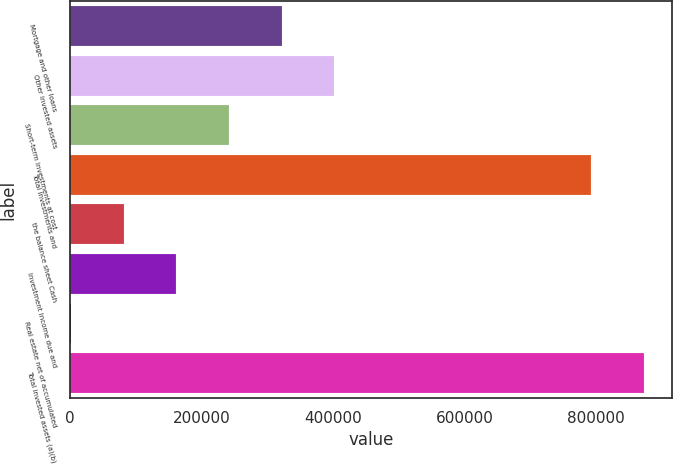Convert chart. <chart><loc_0><loc_0><loc_500><loc_500><bar_chart><fcel>Mortgage and other loans<fcel>Other invested assets<fcel>Short-term investments at cost<fcel>Total investments and<fcel>the balance sheet Cash<fcel>Investment income due and<fcel>Real estate net of accumulated<fcel>Total invested assets (a)(b)<nl><fcel>321608<fcel>401664<fcel>241552<fcel>792874<fcel>81441.5<fcel>161497<fcel>1386<fcel>872930<nl></chart> 